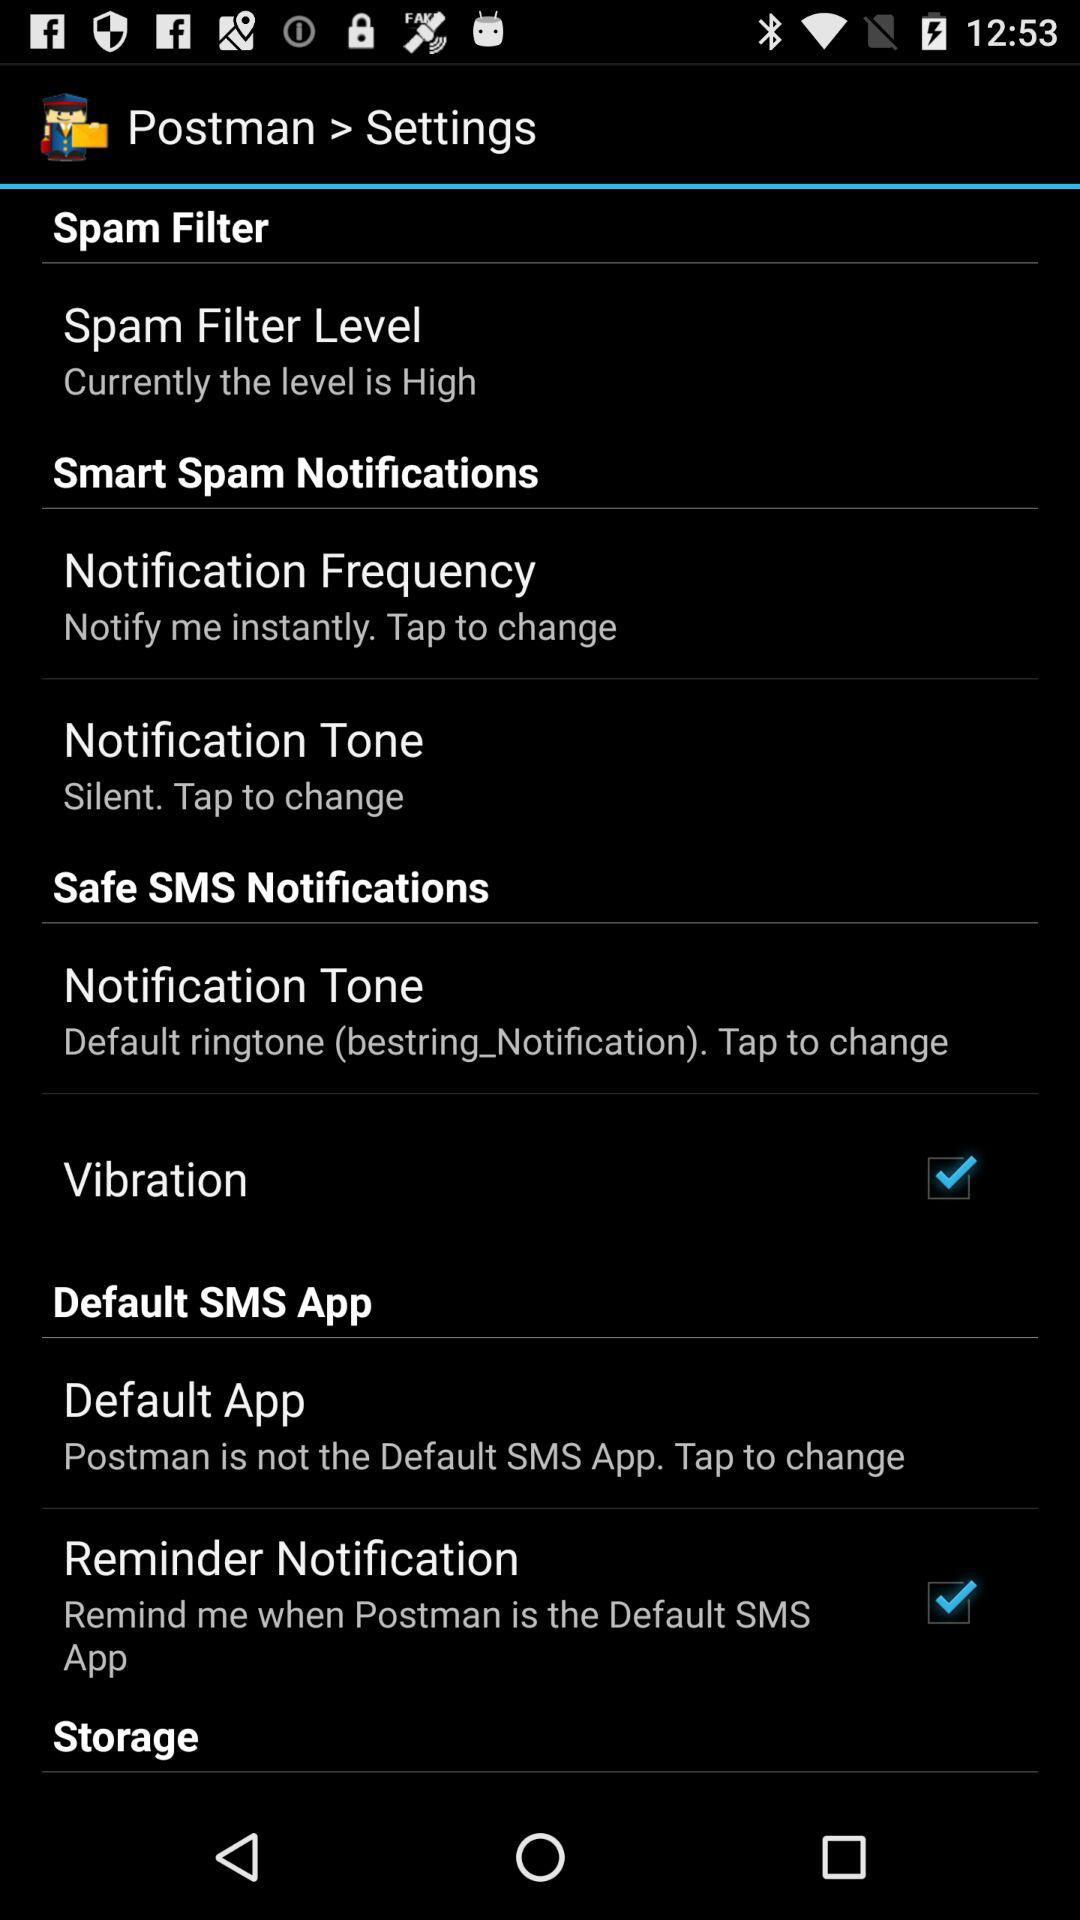What is the setting for notification tone in "Safe SMS Notifications"? The setting is "Default ringtone (bestring_Notification)". 